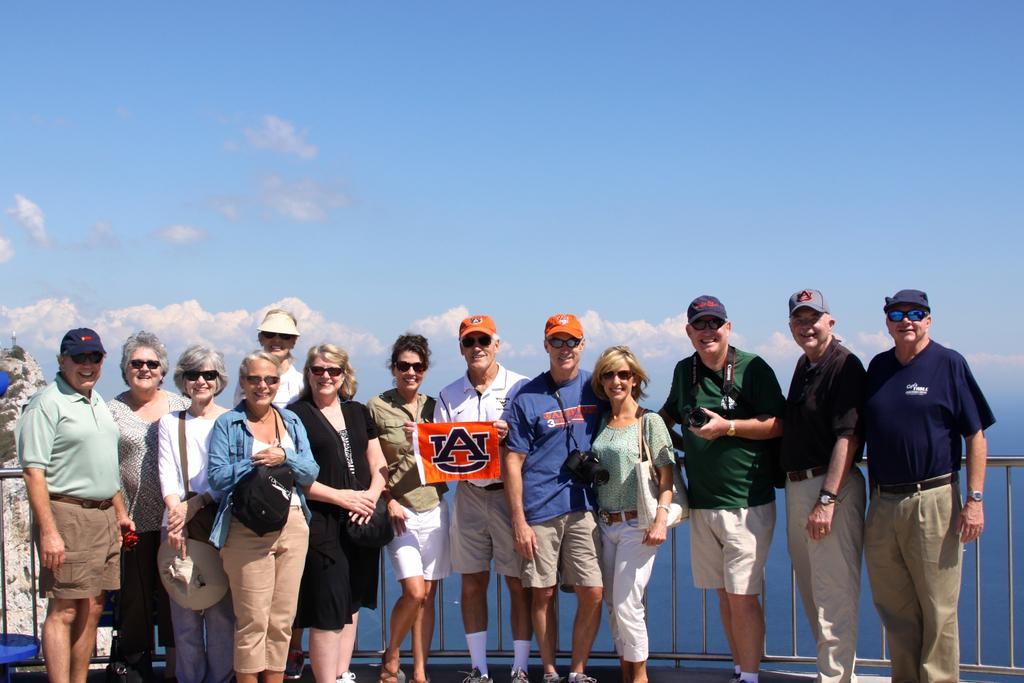What is happening in the image involving a group of people? There is a group of people in the image, and some of them are holding caps and cameras. What is the color of the banner in the image? The banner in the image is orange. Who is holding the banner in the image? The banner is being held by people in the group. What can be seen in the sky in the image? The sky is visible in the image, and it is white and blue. Are there any pets visible in the image? There are no pets present in the image. 